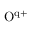<formula> <loc_0><loc_0><loc_500><loc_500>O ^ { q + }</formula> 